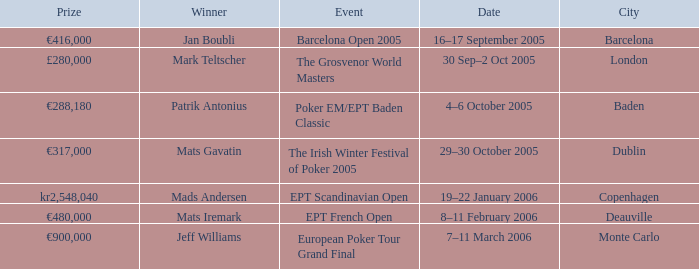Write the full table. {'header': ['Prize', 'Winner', 'Event', 'Date', 'City'], 'rows': [['€416,000', 'Jan Boubli', 'Barcelona Open 2005', '16–17 September 2005', 'Barcelona'], ['£280,000', 'Mark Teltscher', 'The Grosvenor World Masters', '30 Sep–2 Oct 2005', 'London'], ['€288,180', 'Patrik Antonius', 'Poker EM/EPT Baden Classic', '4–6 October 2005', 'Baden'], ['€317,000', 'Mats Gavatin', 'The Irish Winter Festival of Poker 2005', '29–30 October 2005', 'Dublin'], ['kr2,548,040', 'Mads Andersen', 'EPT Scandinavian Open', '19–22 January 2006', 'Copenhagen'], ['€480,000', 'Mats Iremark', 'EPT French Open', '8–11 February 2006', 'Deauville'], ['€900,000', 'Jeff Williams', 'European Poker Tour Grand Final', '7–11 March 2006', 'Monte Carlo']]} When was the event in Dublin? 29–30 October 2005. 